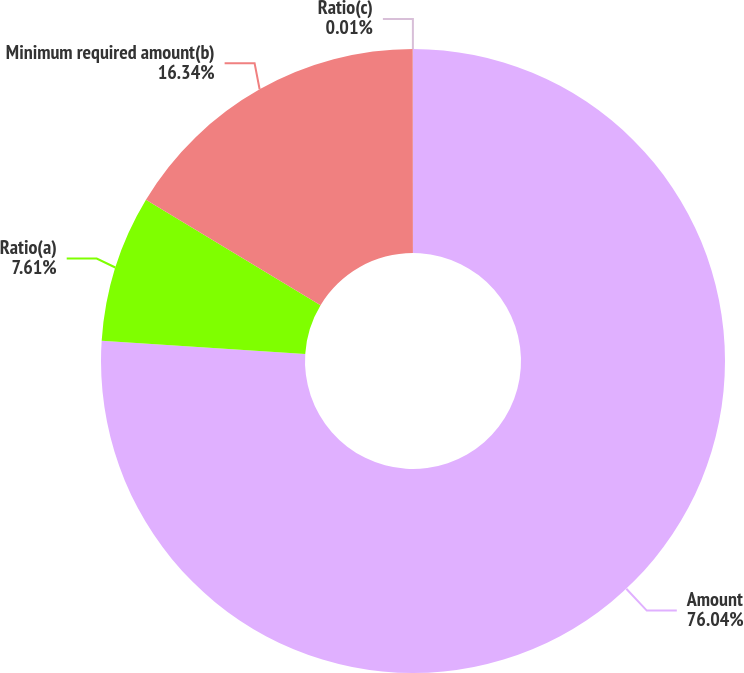Convert chart to OTSL. <chart><loc_0><loc_0><loc_500><loc_500><pie_chart><fcel>Amount<fcel>Ratio(a)<fcel>Minimum required amount(b)<fcel>Ratio(c)<nl><fcel>76.04%<fcel>7.61%<fcel>16.34%<fcel>0.01%<nl></chart> 